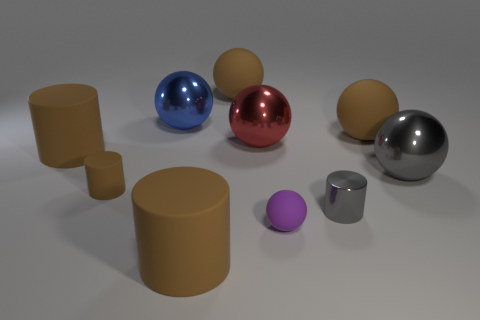Subtract all purple cubes. How many brown cylinders are left? 3 Subtract all blue balls. How many balls are left? 5 Subtract all small spheres. How many spheres are left? 5 Subtract 2 balls. How many balls are left? 4 Subtract all cyan balls. Subtract all yellow cylinders. How many balls are left? 6 Subtract all cylinders. How many objects are left? 6 Add 6 small red matte cylinders. How many small red matte cylinders exist? 6 Subtract 1 gray spheres. How many objects are left? 9 Subtract all tiny spheres. Subtract all small balls. How many objects are left? 8 Add 6 blue spheres. How many blue spheres are left? 7 